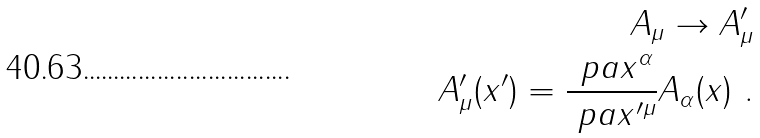<formula> <loc_0><loc_0><loc_500><loc_500>A _ { \mu } \to A ^ { \prime } _ { \mu } \\ A ^ { \prime } _ { \mu } ( x ^ { \prime } ) = \frac { \ p a x ^ { \alpha } } { \ p a x ^ { \prime \mu } } A _ { \alpha } ( x ) \ .</formula> 